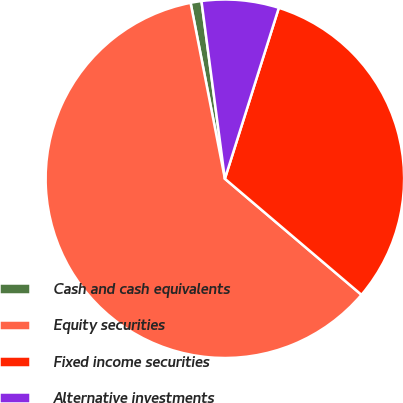Convert chart to OTSL. <chart><loc_0><loc_0><loc_500><loc_500><pie_chart><fcel>Cash and cash equivalents<fcel>Equity securities<fcel>Fixed income securities<fcel>Alternative investments<nl><fcel>0.98%<fcel>60.72%<fcel>31.34%<fcel>6.95%<nl></chart> 